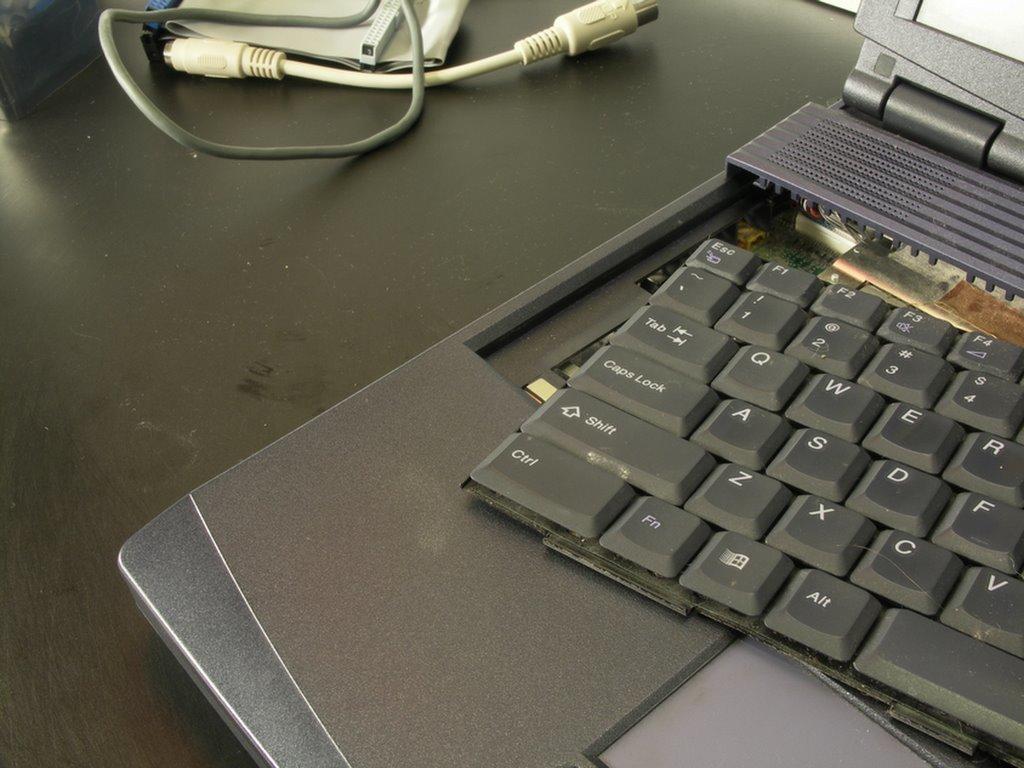What key is on the bottom left?
Your answer should be compact. Ctrl. What is the key to the right of shift?
Ensure brevity in your answer.  Z. 